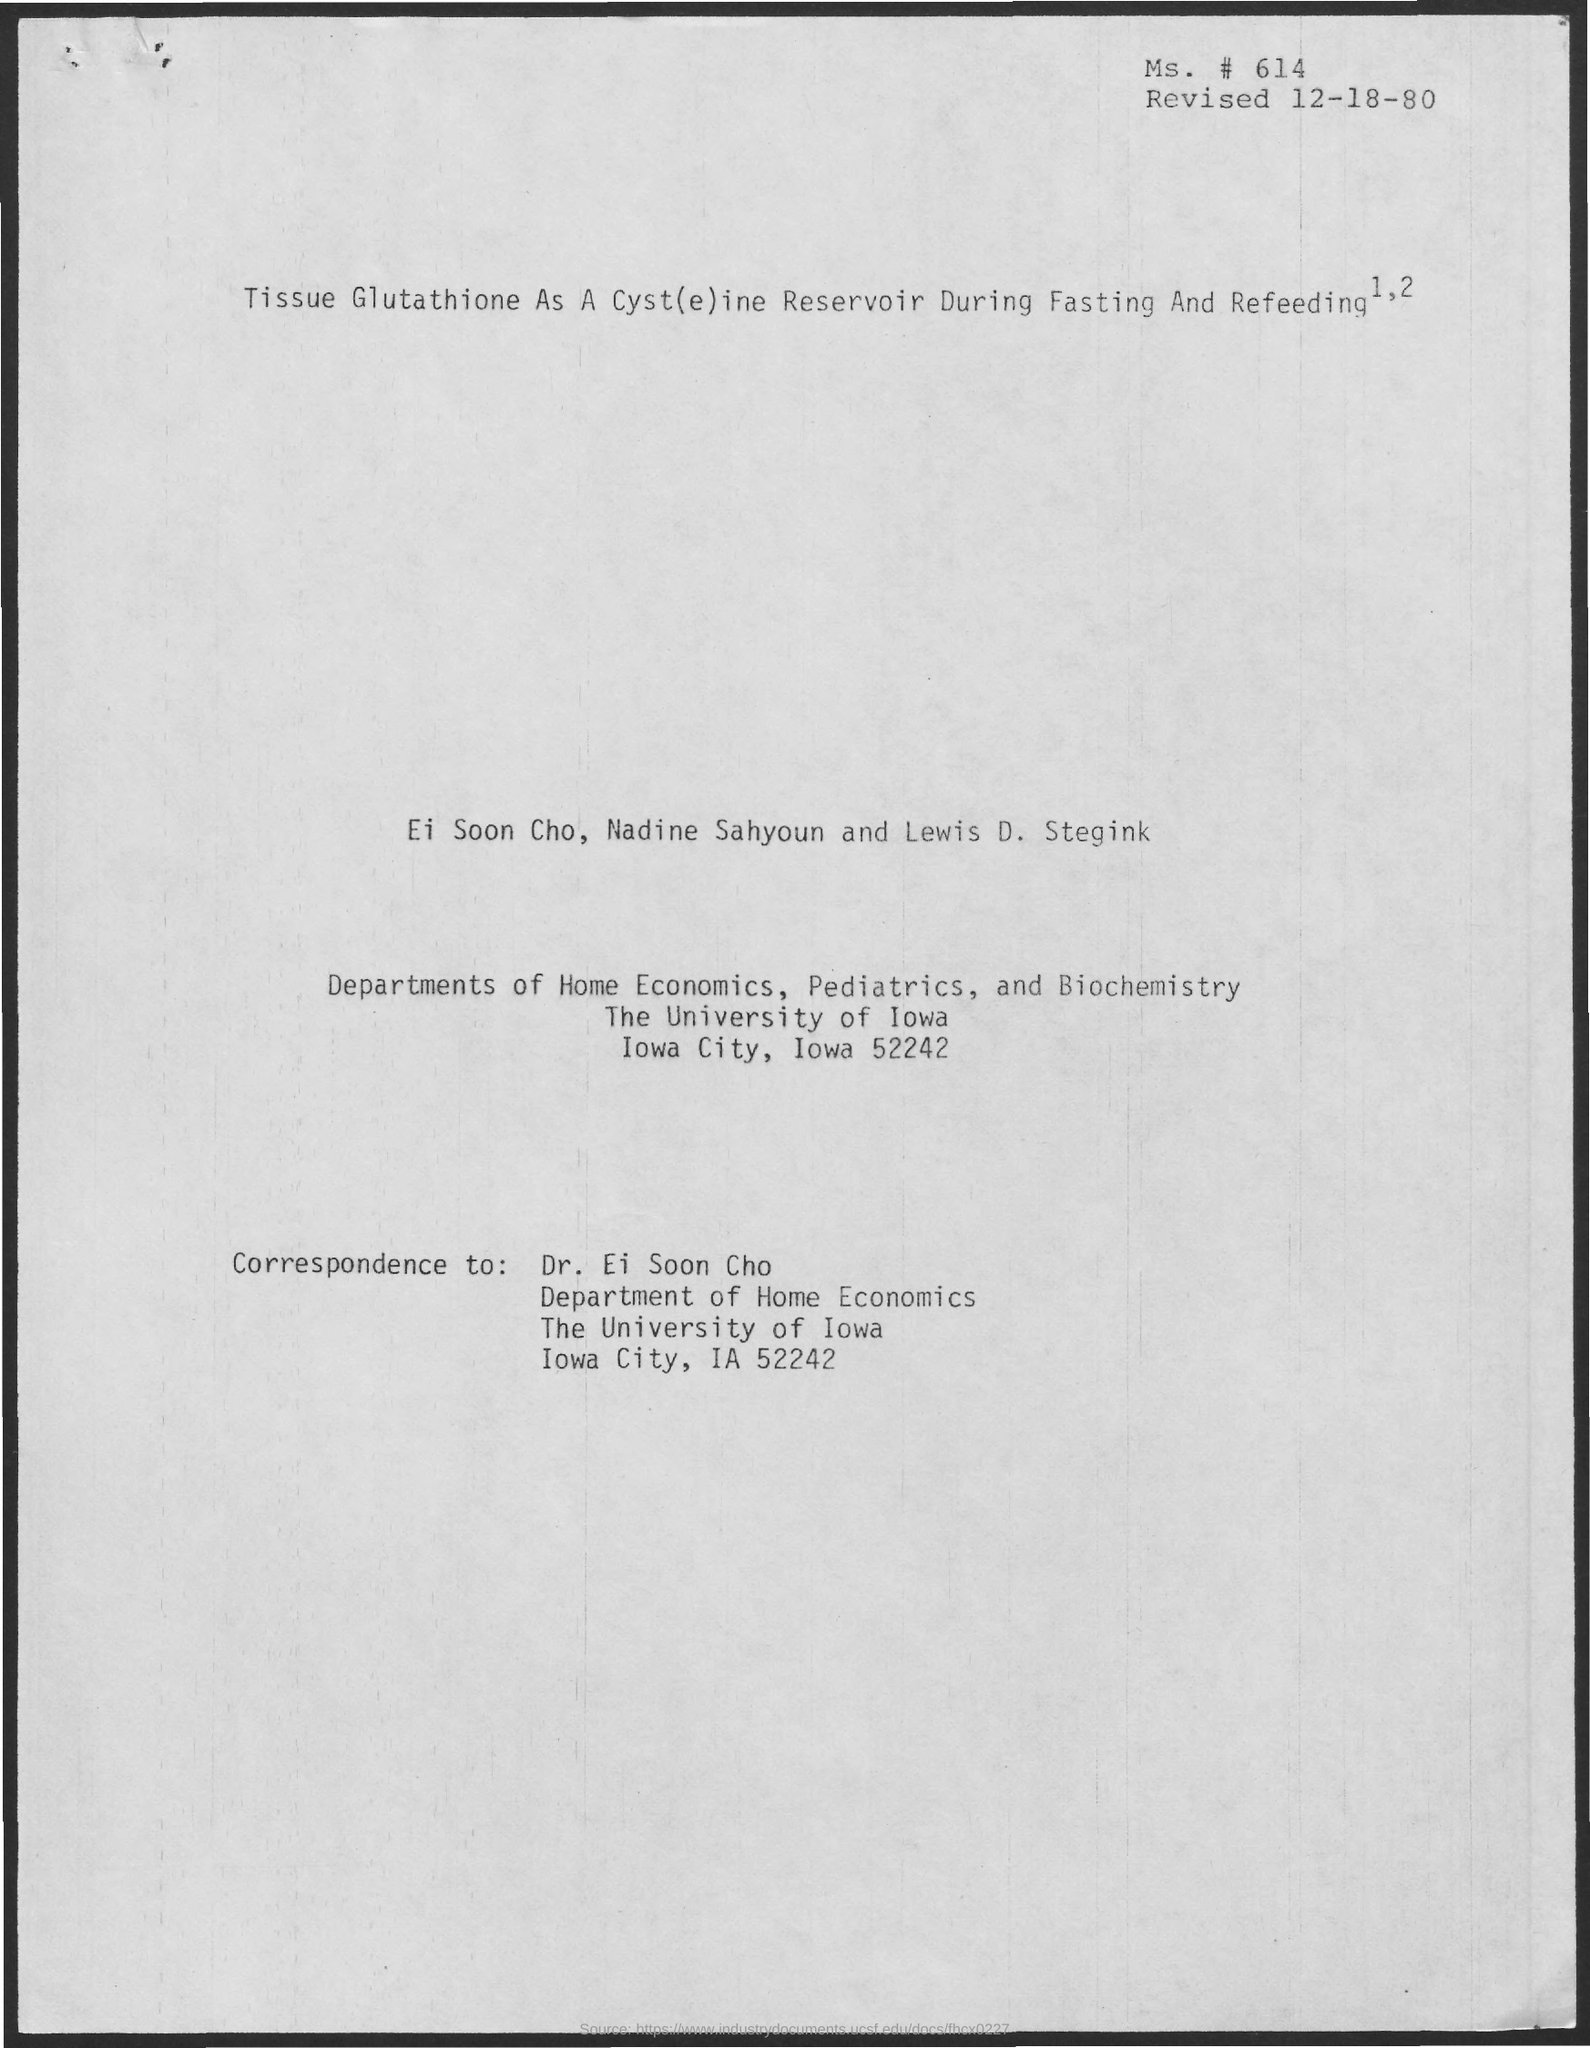Highlight a few significant elements in this photo. The person to whom the correspondence is addressed is Dr. Ei Soon Cho. The document was revised on December 18, 1980. 